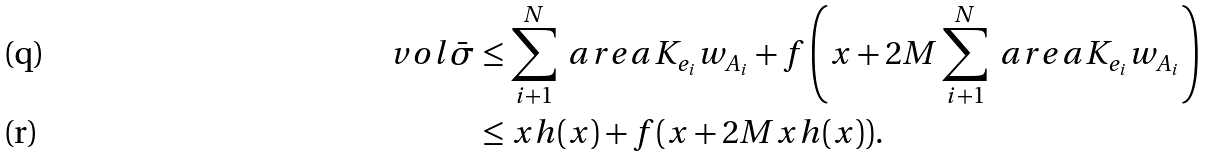Convert formula to latex. <formula><loc_0><loc_0><loc_500><loc_500>\ v o l { \bar { \sigma } } & \leq \sum _ { i + 1 } ^ { N } \ a r e a { K _ { e _ { i } } } { w _ { A _ { i } } } + f \left ( x + 2 M \sum _ { i + 1 } ^ { N } \ a r e a { K _ { e _ { i } } } { w _ { A _ { i } } } \right ) \\ & \leq x h ( x ) + f ( x + 2 M x h ( x ) ) .</formula> 